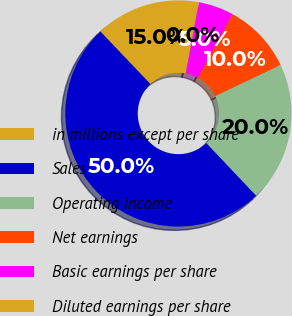Convert chart. <chart><loc_0><loc_0><loc_500><loc_500><pie_chart><fcel>in millions except per share<fcel>Sales<fcel>Operating income<fcel>Net earnings<fcel>Basic earnings per share<fcel>Diluted earnings per share<nl><fcel>15.0%<fcel>49.96%<fcel>20.0%<fcel>10.01%<fcel>5.02%<fcel>0.02%<nl></chart> 